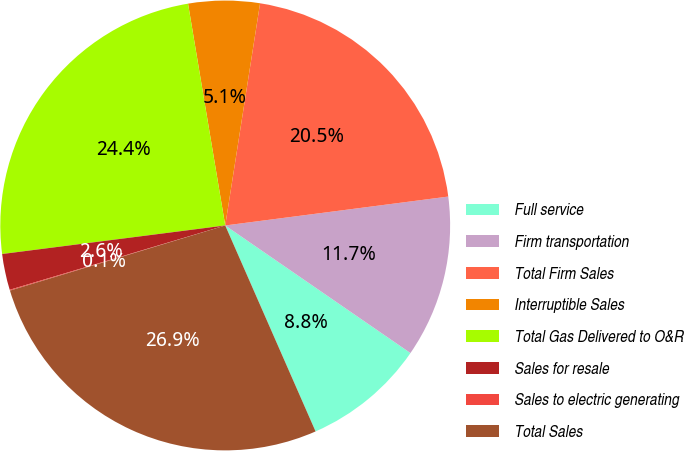<chart> <loc_0><loc_0><loc_500><loc_500><pie_chart><fcel>Full service<fcel>Firm transportation<fcel>Total Firm Sales<fcel>Interruptible Sales<fcel>Total Gas Delivered to O&R<fcel>Sales for resale<fcel>Sales to electric generating<fcel>Total Sales<nl><fcel>8.82%<fcel>11.65%<fcel>20.47%<fcel>5.12%<fcel>24.38%<fcel>2.59%<fcel>0.06%<fcel>26.9%<nl></chart> 